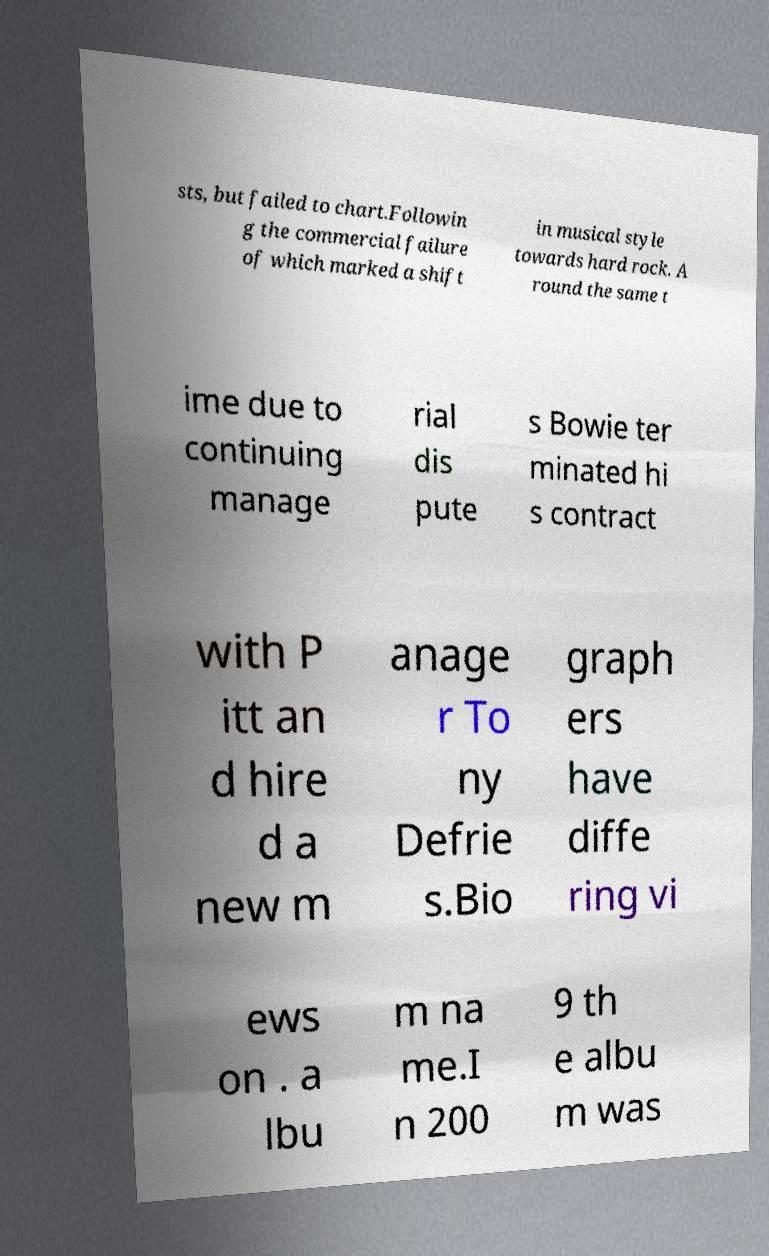For documentation purposes, I need the text within this image transcribed. Could you provide that? sts, but failed to chart.Followin g the commercial failure of which marked a shift in musical style towards hard rock. A round the same t ime due to continuing manage rial dis pute s Bowie ter minated hi s contract with P itt an d hire d a new m anage r To ny Defrie s.Bio graph ers have diffe ring vi ews on . a lbu m na me.I n 200 9 th e albu m was 